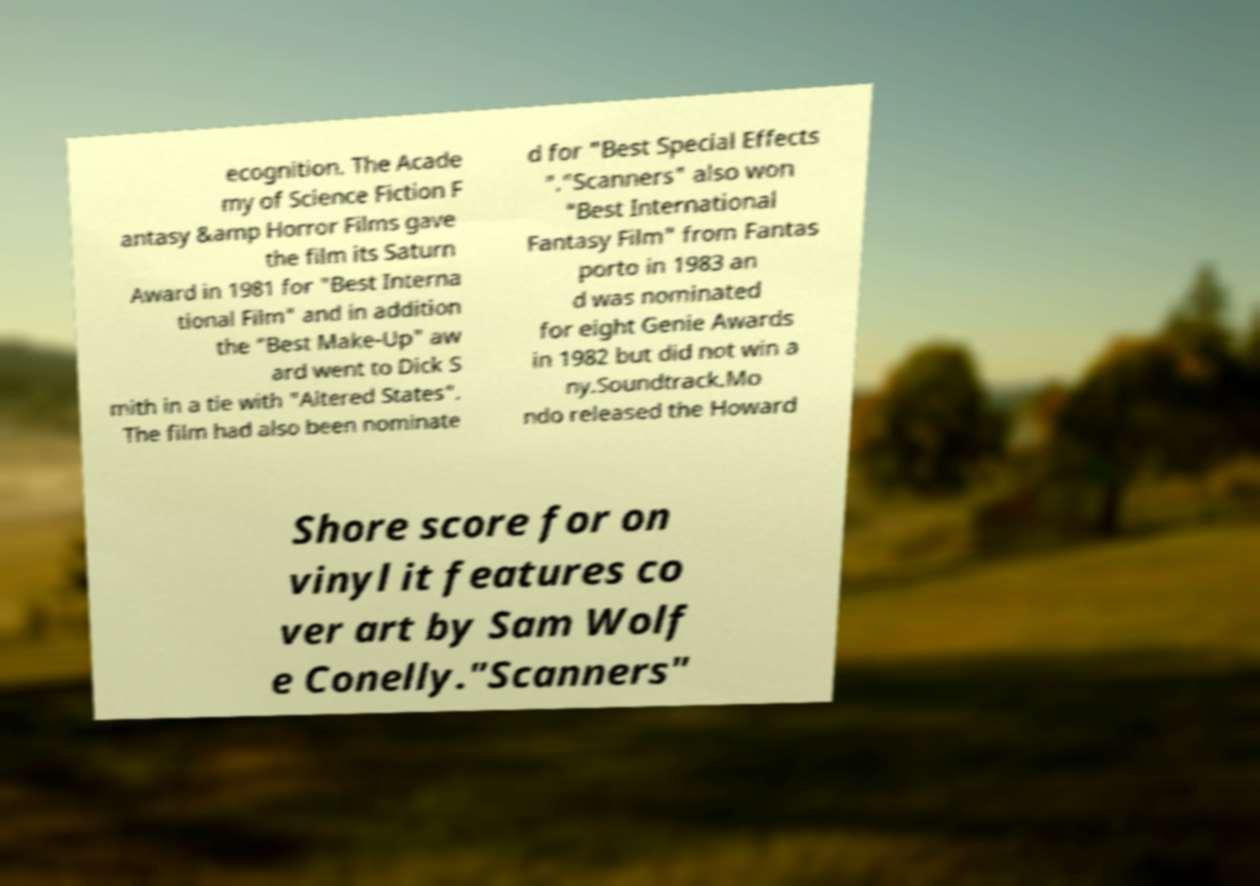Please identify and transcribe the text found in this image. ecognition. The Acade my of Science Fiction F antasy &amp Horror Films gave the film its Saturn Award in 1981 for "Best Interna tional Film" and in addition the "Best Make-Up" aw ard went to Dick S mith in a tie with "Altered States". The film had also been nominate d for "Best Special Effects "."Scanners" also won "Best International Fantasy Film" from Fantas porto in 1983 an d was nominated for eight Genie Awards in 1982 but did not win a ny.Soundtrack.Mo ndo released the Howard Shore score for on vinyl it features co ver art by Sam Wolf e Conelly."Scanners" 